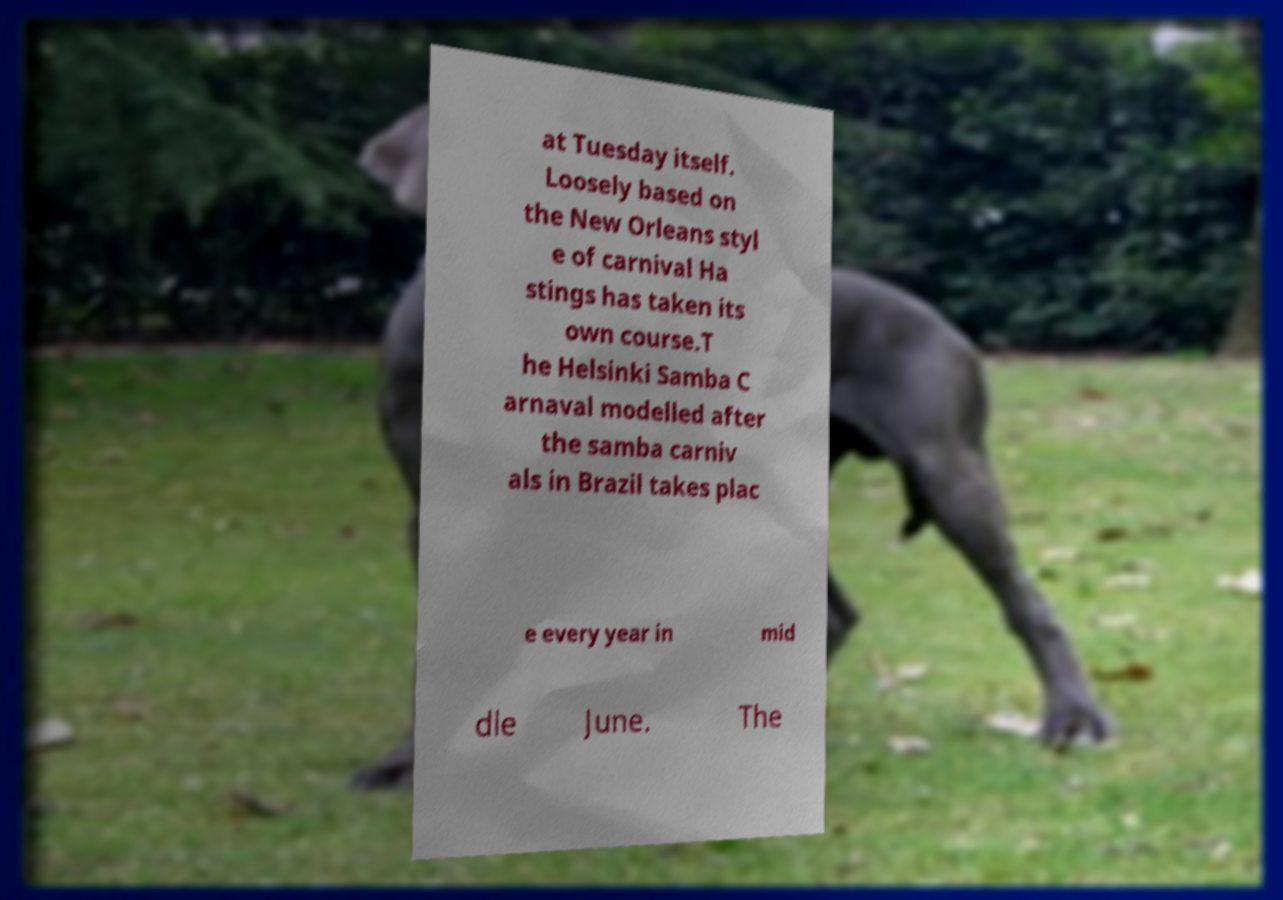For documentation purposes, I need the text within this image transcribed. Could you provide that? at Tuesday itself. Loosely based on the New Orleans styl e of carnival Ha stings has taken its own course.T he Helsinki Samba C arnaval modelled after the samba carniv als in Brazil takes plac e every year in mid dle June. The 